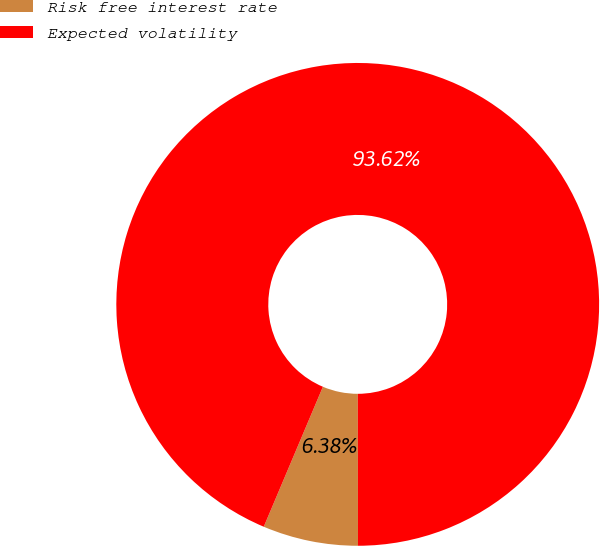<chart> <loc_0><loc_0><loc_500><loc_500><pie_chart><fcel>Risk free interest rate<fcel>Expected volatility<nl><fcel>6.38%<fcel>93.62%<nl></chart> 